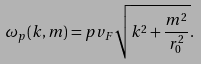Convert formula to latex. <formula><loc_0><loc_0><loc_500><loc_500>\omega _ { p } ( k , m ) = p v _ { F } \sqrt { k ^ { 2 } + \frac { m ^ { 2 } } { r _ { 0 } ^ { 2 } } } .</formula> 